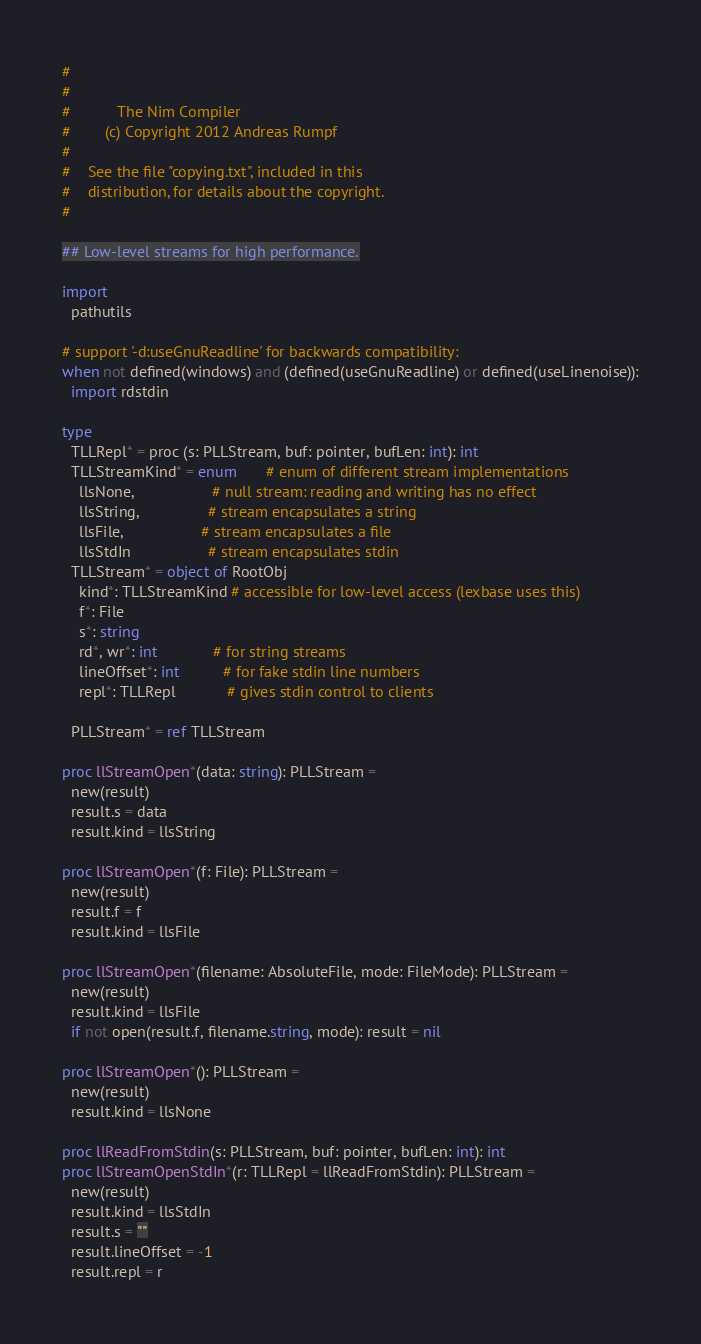<code> <loc_0><loc_0><loc_500><loc_500><_Nim_>#
#
#           The Nim Compiler
#        (c) Copyright 2012 Andreas Rumpf
#
#    See the file "copying.txt", included in this
#    distribution, for details about the copyright.
#

## Low-level streams for high performance.

import
  pathutils

# support '-d:useGnuReadline' for backwards compatibility:
when not defined(windows) and (defined(useGnuReadline) or defined(useLinenoise)):
  import rdstdin

type
  TLLRepl* = proc (s: PLLStream, buf: pointer, bufLen: int): int
  TLLStreamKind* = enum       # enum of different stream implementations
    llsNone,                  # null stream: reading and writing has no effect
    llsString,                # stream encapsulates a string
    llsFile,                  # stream encapsulates a file
    llsStdIn                  # stream encapsulates stdin
  TLLStream* = object of RootObj
    kind*: TLLStreamKind # accessible for low-level access (lexbase uses this)
    f*: File
    s*: string
    rd*, wr*: int             # for string streams
    lineOffset*: int          # for fake stdin line numbers
    repl*: TLLRepl            # gives stdin control to clients

  PLLStream* = ref TLLStream

proc llStreamOpen*(data: string): PLLStream =
  new(result)
  result.s = data
  result.kind = llsString

proc llStreamOpen*(f: File): PLLStream =
  new(result)
  result.f = f
  result.kind = llsFile

proc llStreamOpen*(filename: AbsoluteFile, mode: FileMode): PLLStream =
  new(result)
  result.kind = llsFile
  if not open(result.f, filename.string, mode): result = nil

proc llStreamOpen*(): PLLStream =
  new(result)
  result.kind = llsNone

proc llReadFromStdin(s: PLLStream, buf: pointer, bufLen: int): int
proc llStreamOpenStdIn*(r: TLLRepl = llReadFromStdin): PLLStream =
  new(result)
  result.kind = llsStdIn
  result.s = ""
  result.lineOffset = -1
  result.repl = r
</code> 